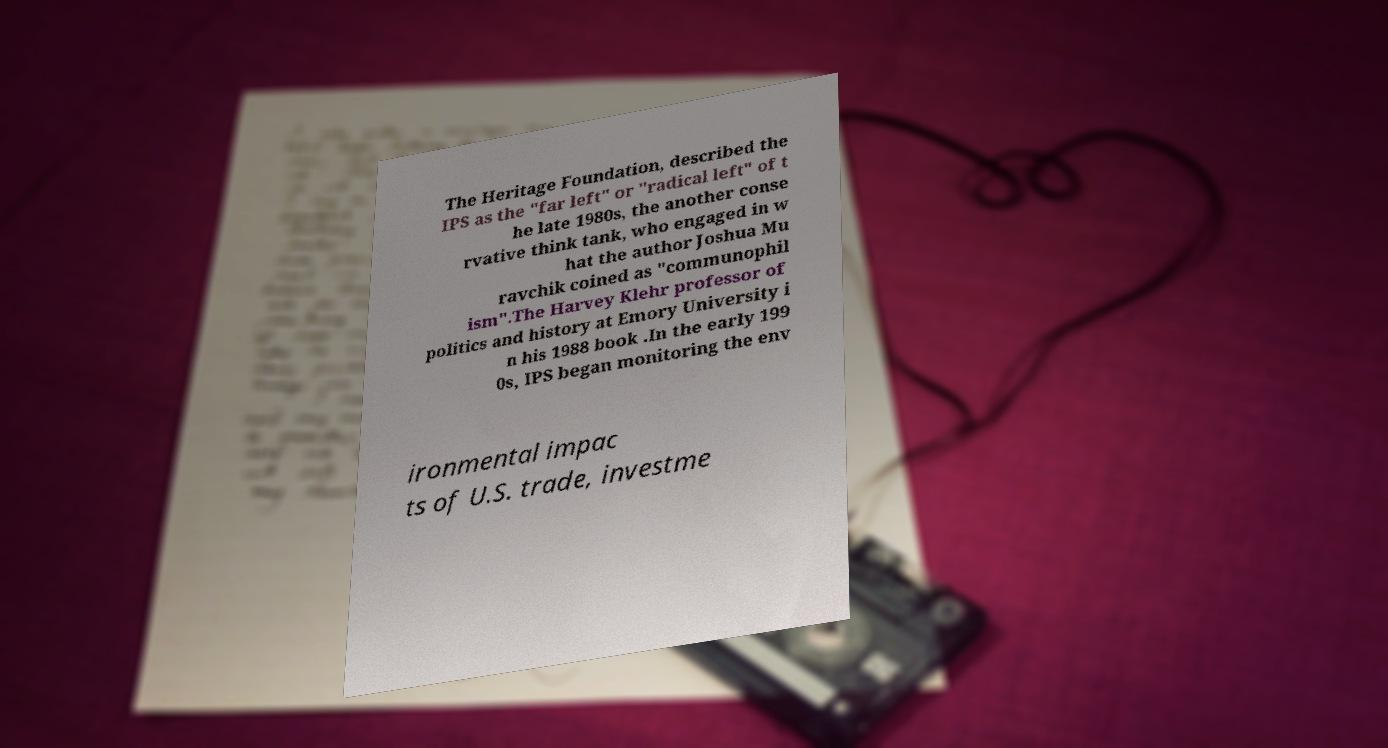Could you extract and type out the text from this image? The Heritage Foundation, described the IPS as the "far left" or "radical left" of t he late 1980s, the another conse rvative think tank, who engaged in w hat the author Joshua Mu ravchik coined as "communophil ism".The Harvey Klehr professor of politics and history at Emory University i n his 1988 book .In the early 199 0s, IPS began monitoring the env ironmental impac ts of U.S. trade, investme 